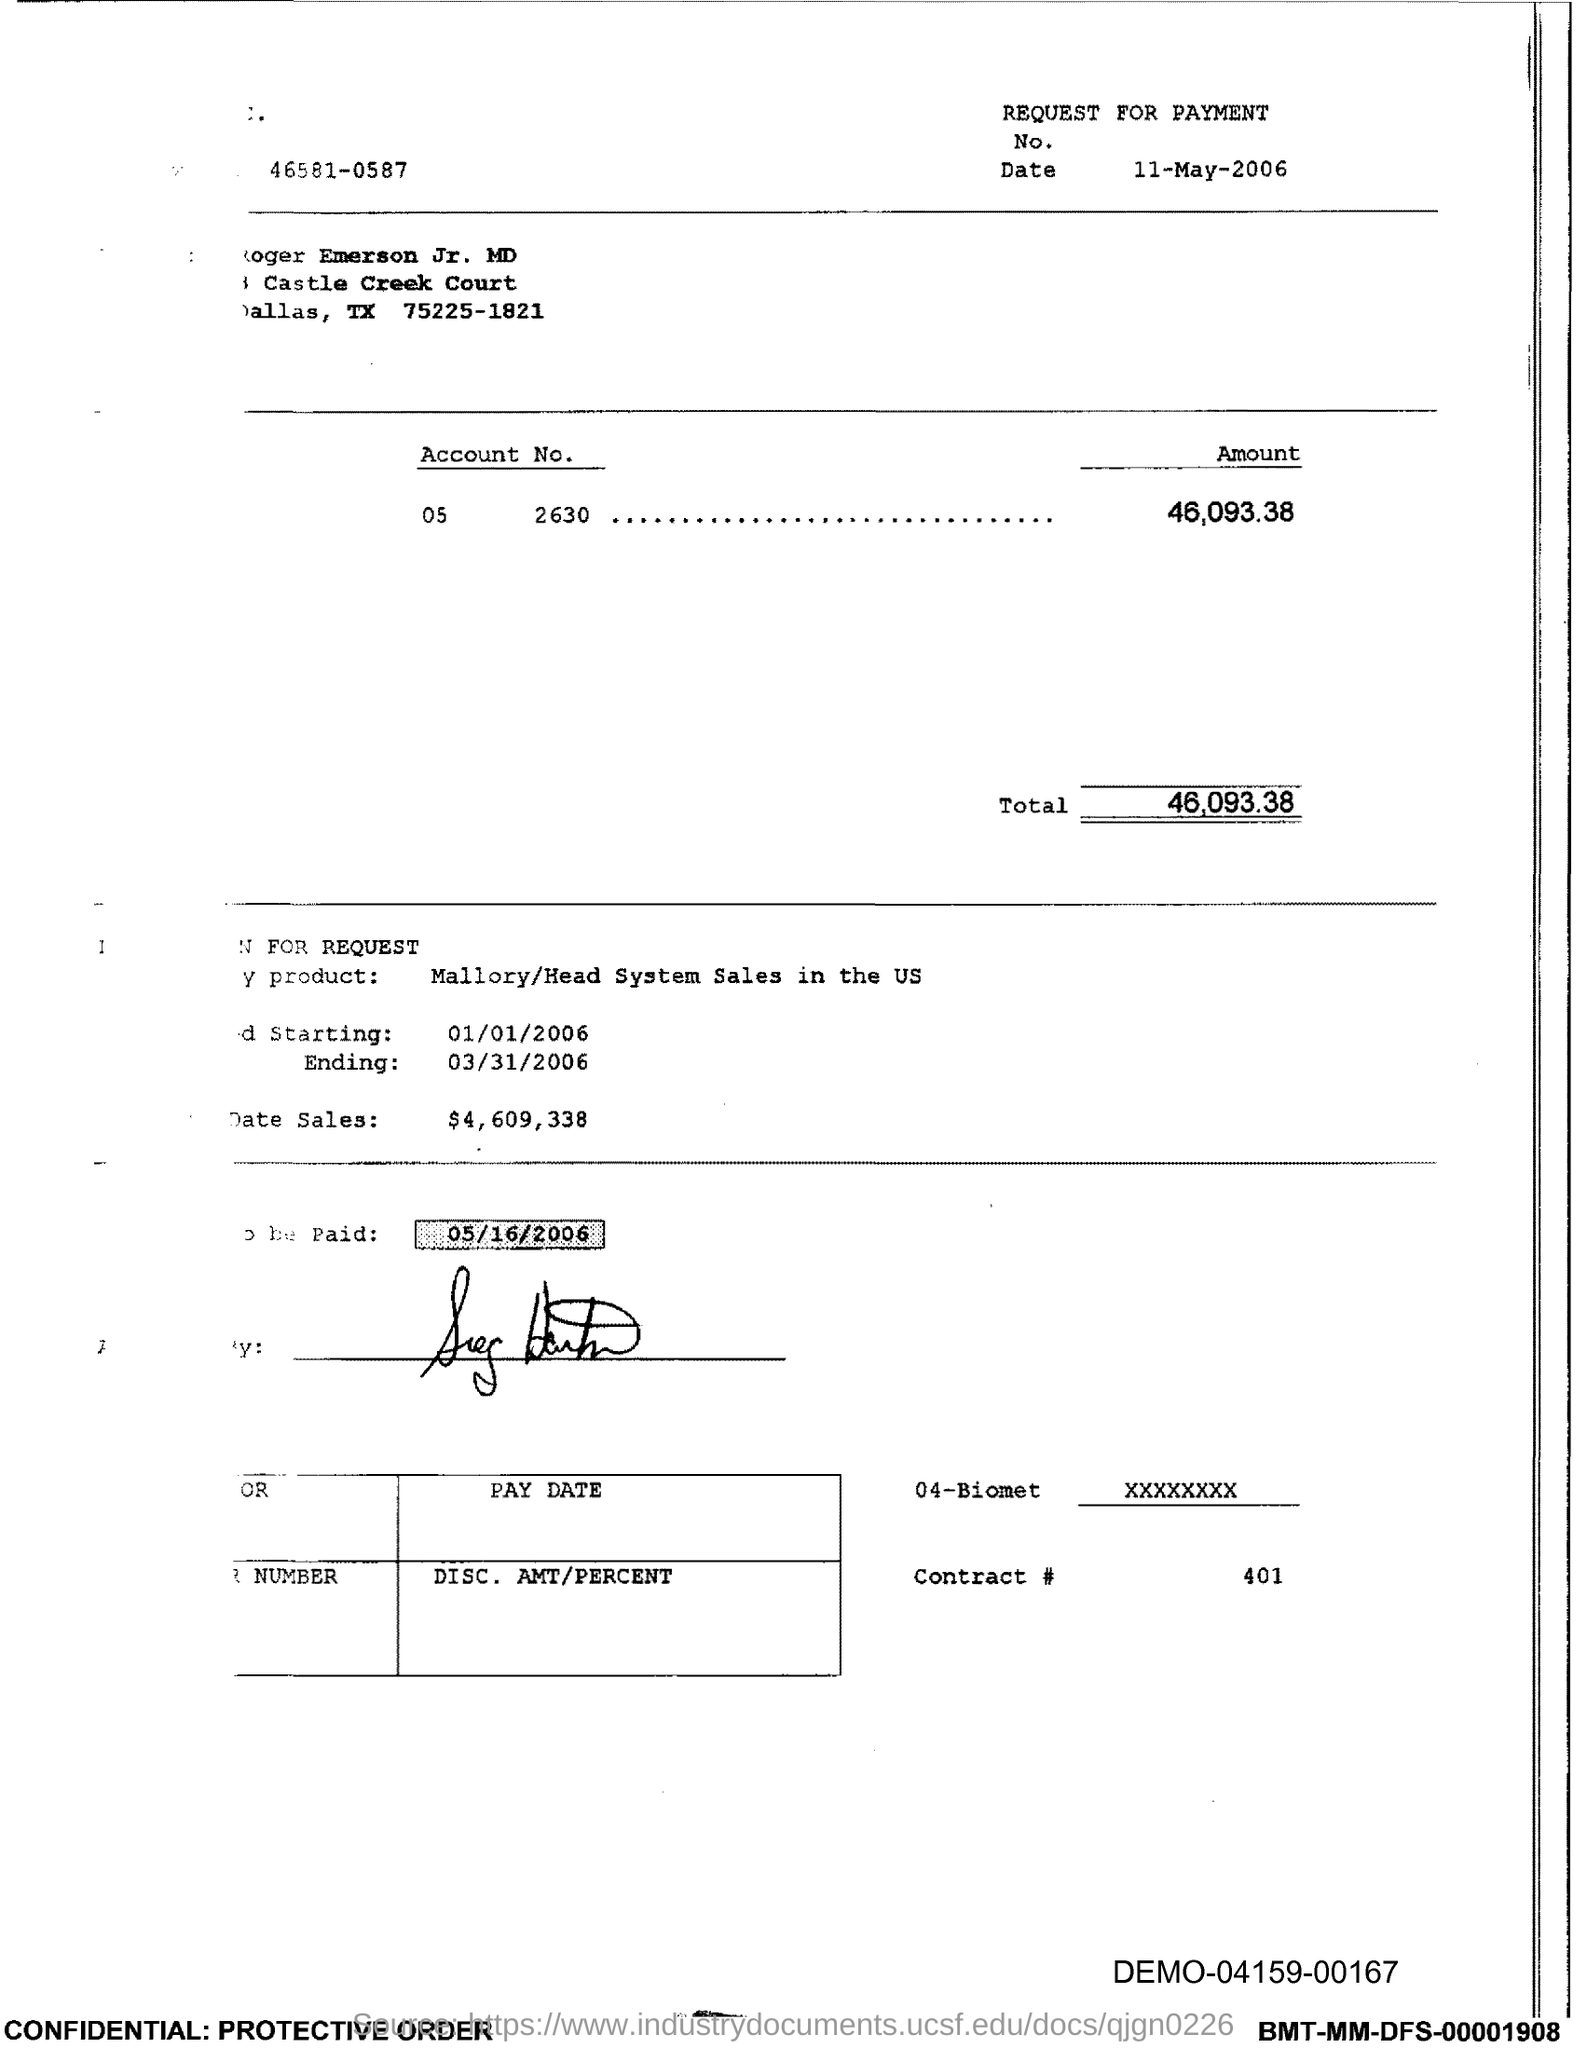What is the amount in the document?
Offer a very short reply. 46,093.38. What is the Total?
Offer a very short reply. 46,093.38. 